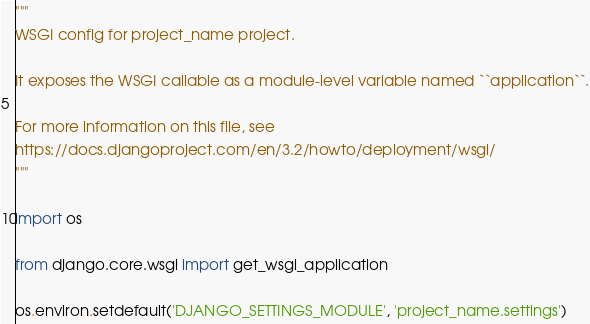Convert code to text. <code><loc_0><loc_0><loc_500><loc_500><_Python_>"""
WSGI config for project_name project.

It exposes the WSGI callable as a module-level variable named ``application``.

For more information on this file, see
https://docs.djangoproject.com/en/3.2/howto/deployment/wsgi/
"""

import os

from django.core.wsgi import get_wsgi_application

os.environ.setdefault('DJANGO_SETTINGS_MODULE', 'project_name.settings')
</code> 